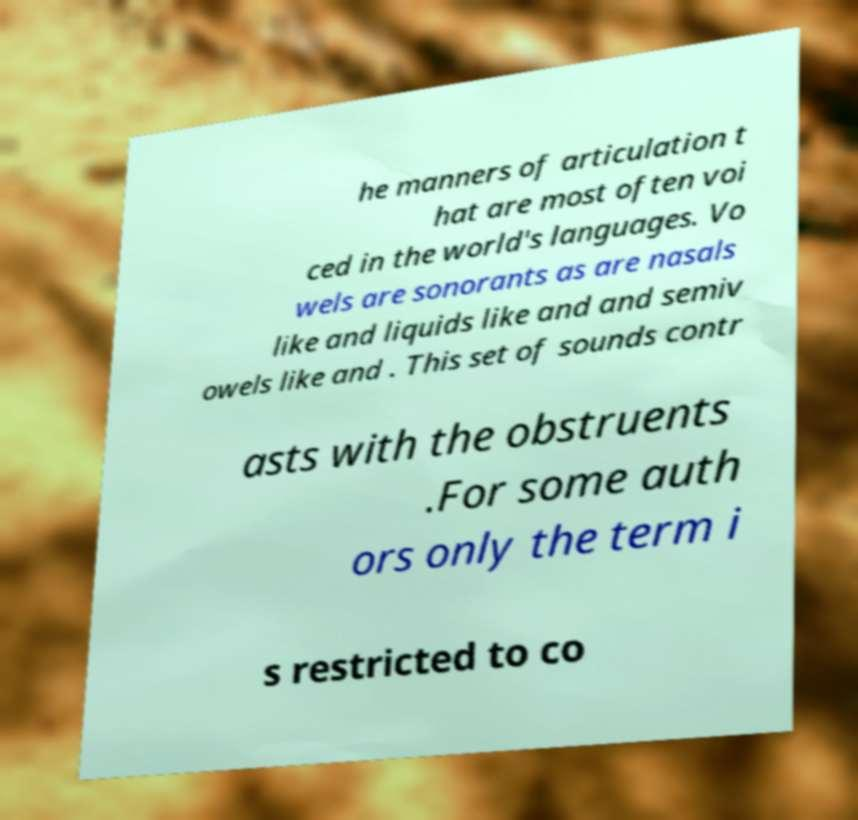Please read and relay the text visible in this image. What does it say? he manners of articulation t hat are most often voi ced in the world's languages. Vo wels are sonorants as are nasals like and liquids like and and semiv owels like and . This set of sounds contr asts with the obstruents .For some auth ors only the term i s restricted to co 